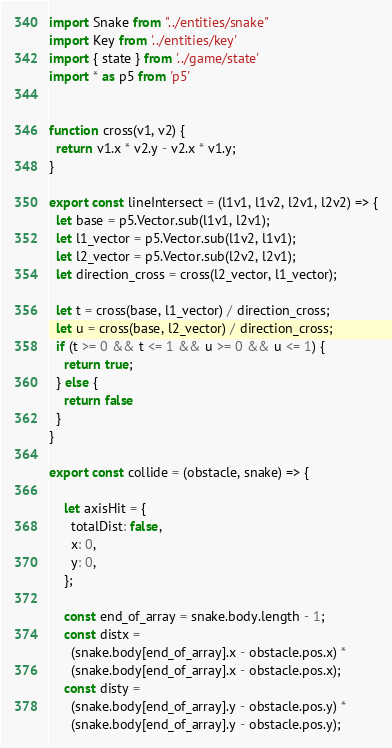Convert code to text. <code><loc_0><loc_0><loc_500><loc_500><_JavaScript_>import Snake from "../entities/snake"
import Key from '../entities/key'
import { state } from '../game/state'
import * as p5 from 'p5'


function cross(v1, v2) {
  return v1.x * v2.y - v2.x * v1.y;
}

export const lineIntersect = (l1v1, l1v2, l2v1, l2v2) => {
  let base = p5.Vector.sub(l1v1, l2v1);
  let l1_vector = p5.Vector.sub(l1v2, l1v1);
  let l2_vector = p5.Vector.sub(l2v2, l2v1);
  let direction_cross = cross(l2_vector, l1_vector);

  let t = cross(base, l1_vector) / direction_cross;
  let u = cross(base, l2_vector) / direction_cross;
  if (t >= 0 && t <= 1 && u >= 0 && u <= 1) {
    return true;
  } else {
    return false
  }
}

export const collide = (obstacle, snake) => {
  
    let axisHit = {
      totalDist: false,
      x: 0,
      y: 0,
    };

    const end_of_array = snake.body.length - 1;
    const distx =
      (snake.body[end_of_array].x - obstacle.pos.x) *
      (snake.body[end_of_array].x - obstacle.pos.x);
    const disty =
      (snake.body[end_of_array].y - obstacle.pos.y) *
      (snake.body[end_of_array].y - obstacle.pos.y);
</code> 